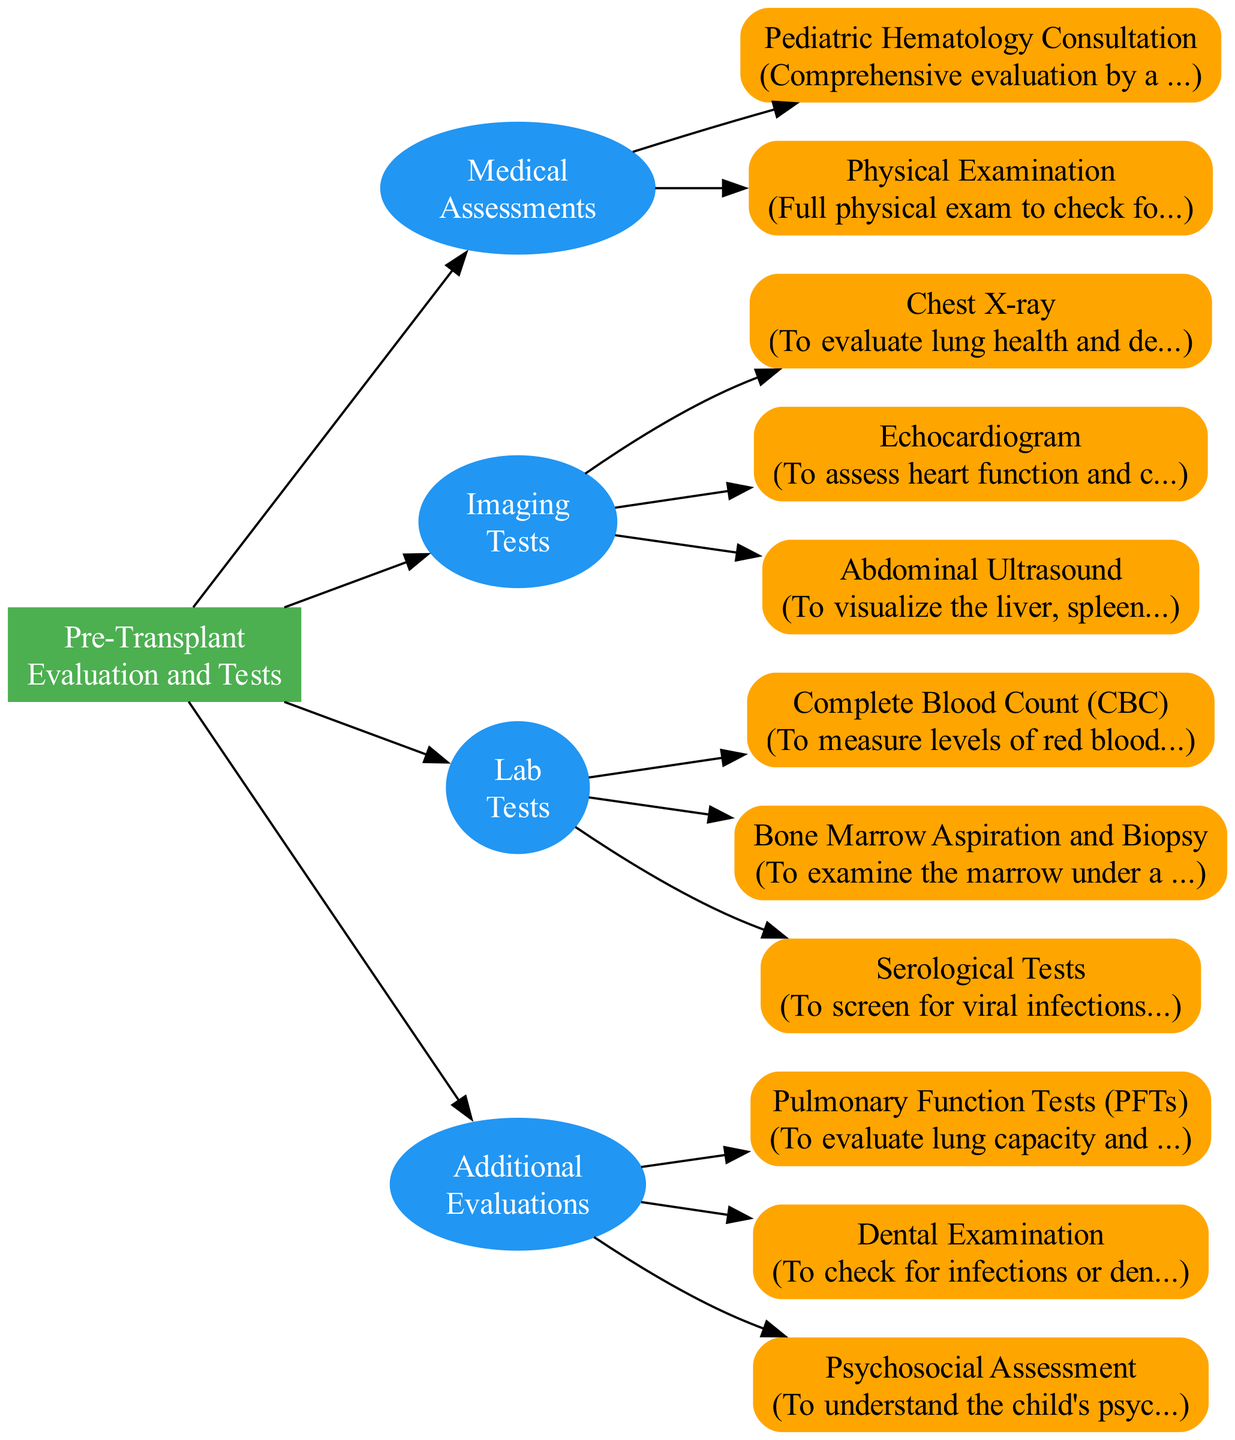What is the first node in the diagram? The first node in the diagram represents the overarching category of the pathway, which is labeled "Pre-Transplant Evaluation and Tests."
Answer: Pre-Transplant Evaluation and Tests How many categories are there in the diagram? The diagram displays four distinct categories related to the pre-transplant process, which are Medical Assessments, Imaging Tests, Lab Tests, and Additional Evaluations.
Answer: 4 What type of evaluation is included in Medical Assessments? Within the Medical Assessments category, the diagram includes a Pediatric Hematology Consultation to evaluate the patient's overall health.
Answer: Pediatric Hematology Consultation Which imaging test assesses lung health? The chest X-ray is specifically indicated in the diagram to evaluate lung health and check for any lung infections.
Answer: Chest X-ray Which lab test is meant to examine the marrow? The Bone Marrow Aspiration and Biopsy is the lab test identified in the diagram for examining the marrow under a microscope.
Answer: Bone Marrow Aspiration and Biopsy What additional evaluation checks dental issues? The Dental Examination is an additional evaluation included in the diagram to address any infections or dental problems before the transplant.
Answer: Dental Examination How many lab tests are listed in the diagram? The diagram provides three lab tests that must be completed as part of the pre-transplant evaluation process. They are labeled as Complete Blood Count, Bone Marrow Aspiration and Biopsy, and Serological Tests.
Answer: 3 What is the purpose of the Psychosocial Assessment? The Psychosocial Assessment aims to evaluate the child's psychological and social support needs, ensuring comprehensive care before the transplant.
Answer: Psychological and social support needs Which test assesses heart function? The Echocardiogram is indicated in the diagram as the imaging test used to assess heart function and check for any cardiac issues.
Answer: Echocardiogram 